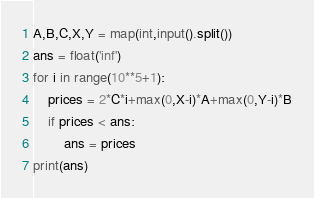Convert code to text. <code><loc_0><loc_0><loc_500><loc_500><_Python_>A,B,C,X,Y = map(int,input().split())
ans = float('inf')
for i in range(10**5+1):
    prices = 2*C*i+max(0,X-i)*A+max(0,Y-i)*B
    if prices < ans:
        ans = prices
print(ans)</code> 